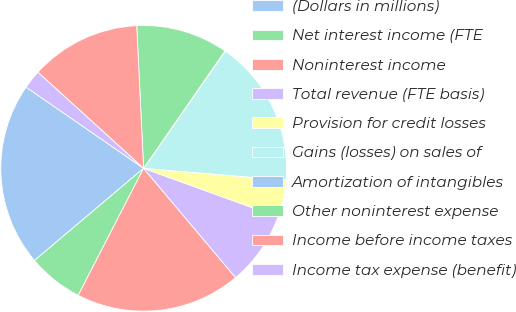Convert chart. <chart><loc_0><loc_0><loc_500><loc_500><pie_chart><fcel>(Dollars in millions)<fcel>Net interest income (FTE<fcel>Noninterest income<fcel>Total revenue (FTE basis)<fcel>Provision for credit losses<fcel>Gains (losses) on sales of<fcel>Amortization of intangibles<fcel>Other noninterest expense<fcel>Income before income taxes<fcel>Income tax expense (benefit)<nl><fcel>20.78%<fcel>6.27%<fcel>18.7%<fcel>8.34%<fcel>4.2%<fcel>16.63%<fcel>0.05%<fcel>10.41%<fcel>12.49%<fcel>2.12%<nl></chart> 